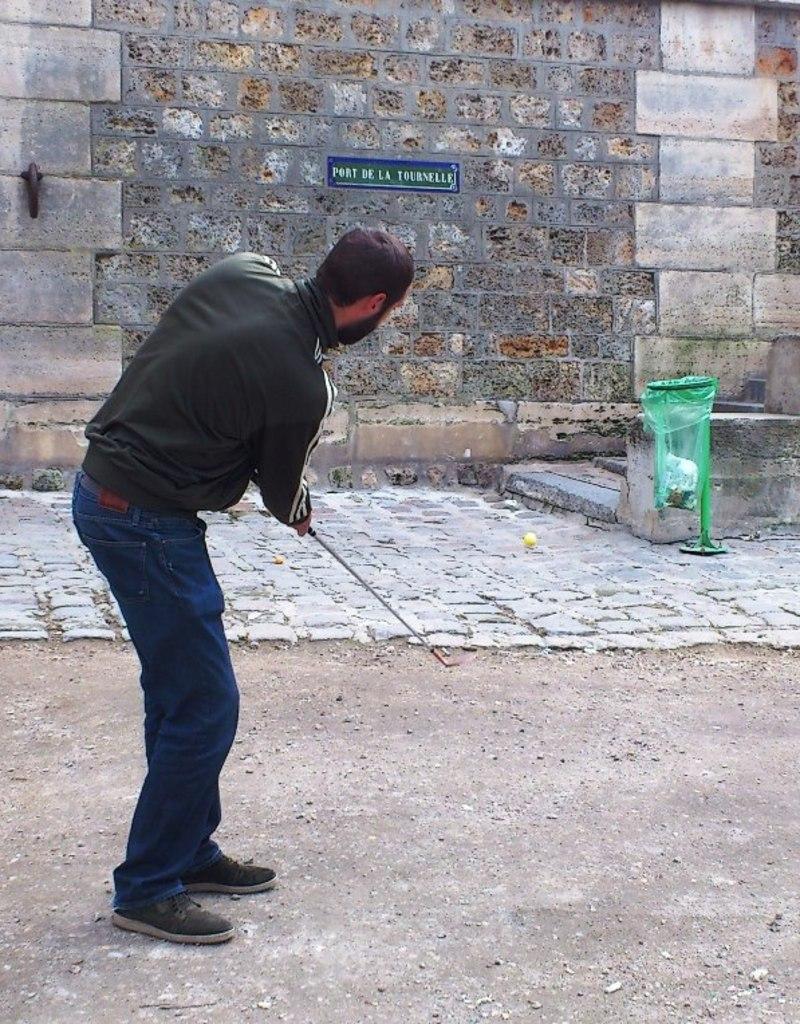In one or two sentences, can you explain what this image depicts? In this image we can see a man is standing on the ground and holding a bat in the hands. In the background we can see a ball in the air, dustbin stand, name board and metal object on the wall. 